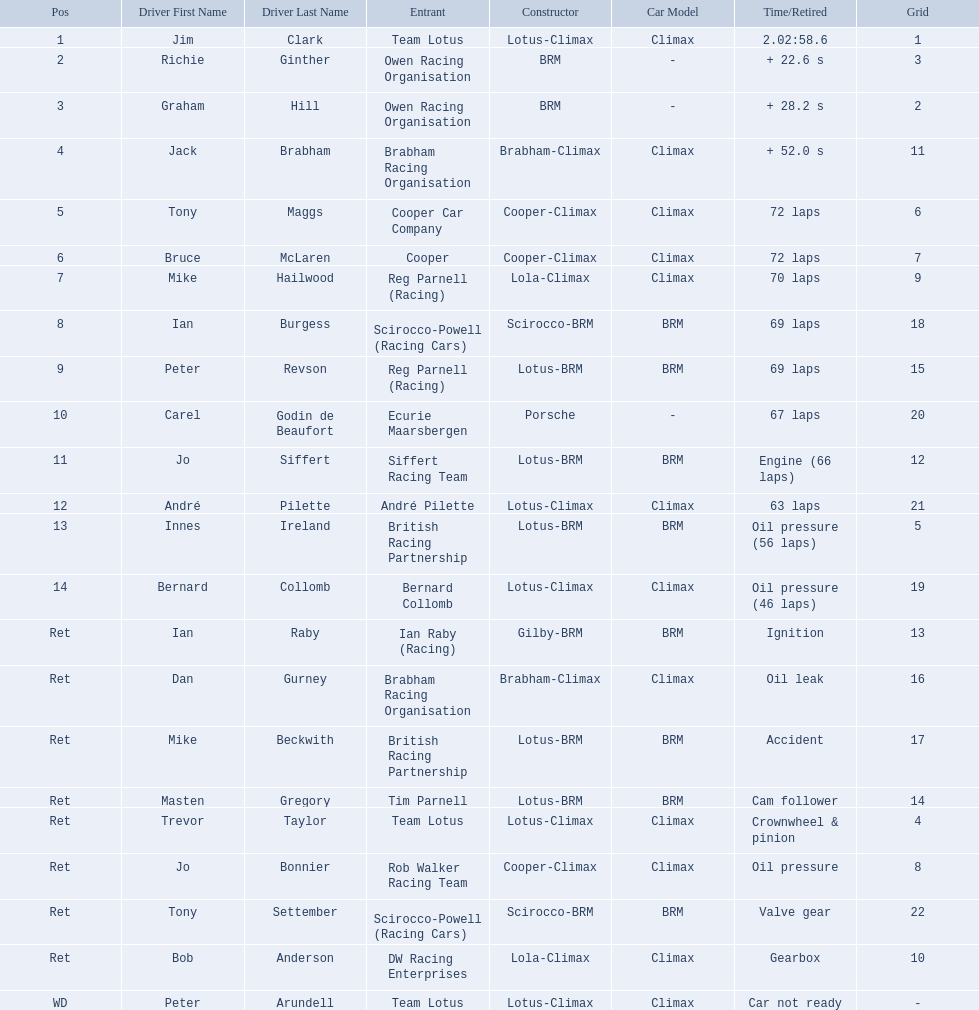Who are all the drivers? Jim Clark, Richie Ginther, Graham Hill, Jack Brabham, Tony Maggs, Bruce McLaren, Mike Hailwood, Ian Burgess, Peter Revson, Carel Godin de Beaufort, Jo Siffert, André Pilette, Innes Ireland, Bernard Collomb, Ian Raby, Dan Gurney, Mike Beckwith, Masten Gregory, Trevor Taylor, Jo Bonnier, Tony Settember, Bob Anderson, Peter Arundell. What were their positions? 1, 2, 3, 4, 5, 6, 7, 8, 9, 10, 11, 12, 13, 14, Ret, Ret, Ret, Ret, Ret, Ret, Ret, Ret, WD. What are all the constructor names? Lotus-Climax, BRM, BRM, Brabham-Climax, Cooper-Climax, Cooper-Climax, Lola-Climax, Scirocco-BRM, Lotus-BRM, Porsche, Lotus-BRM, Lotus-Climax, Lotus-BRM, Lotus-Climax, Gilby-BRM, Brabham-Climax, Lotus-BRM, Lotus-BRM, Lotus-Climax, Cooper-Climax, Scirocco-BRM, Lola-Climax, Lotus-Climax. And which drivers drove a cooper-climax? Tony Maggs, Bruce McLaren. Between those tow, who was positioned higher? Tony Maggs. 